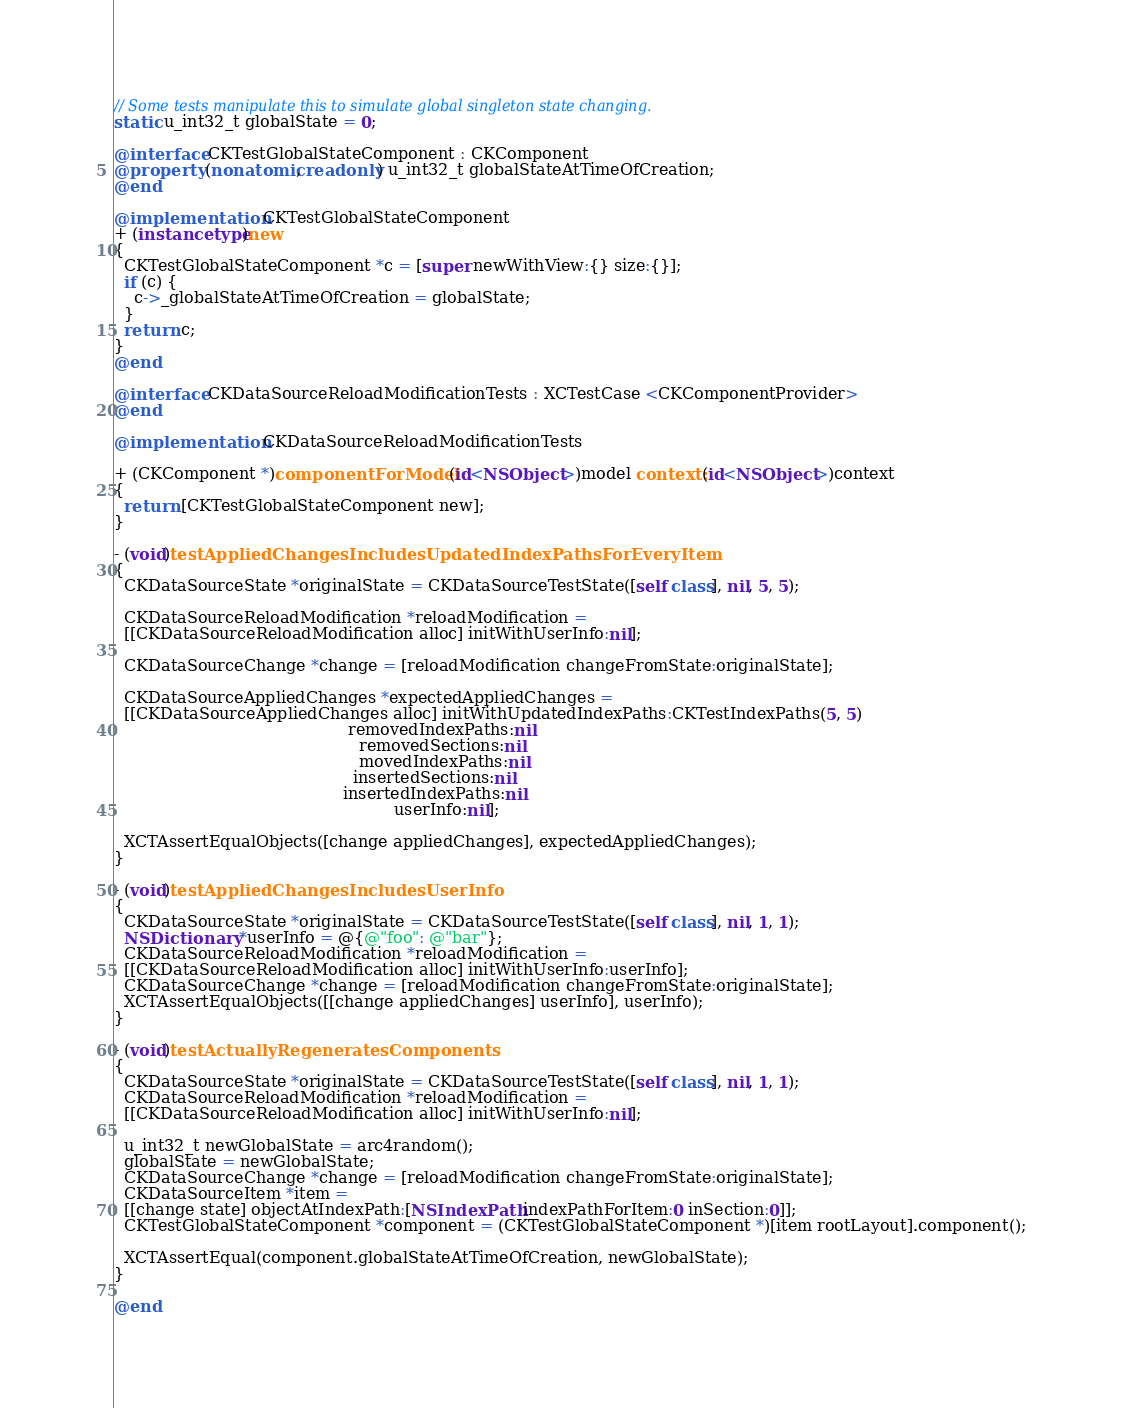<code> <loc_0><loc_0><loc_500><loc_500><_ObjectiveC_>
// Some tests manipulate this to simulate global singleton state changing.
static u_int32_t globalState = 0;

@interface CKTestGlobalStateComponent : CKComponent
@property (nonatomic, readonly) u_int32_t globalStateAtTimeOfCreation;
@end

@implementation CKTestGlobalStateComponent
+ (instancetype)new
{
  CKTestGlobalStateComponent *c = [super newWithView:{} size:{}];
  if (c) {
    c->_globalStateAtTimeOfCreation = globalState;
  }
  return c;
}
@end

@interface CKDataSourceReloadModificationTests : XCTestCase <CKComponentProvider>
@end

@implementation CKDataSourceReloadModificationTests

+ (CKComponent *)componentForModel:(id<NSObject>)model context:(id<NSObject>)context
{
  return [CKTestGlobalStateComponent new];
}

- (void)testAppliedChangesIncludesUpdatedIndexPathsForEveryItem
{
  CKDataSourceState *originalState = CKDataSourceTestState([self class], nil, 5, 5);

  CKDataSourceReloadModification *reloadModification =
  [[CKDataSourceReloadModification alloc] initWithUserInfo:nil];

  CKDataSourceChange *change = [reloadModification changeFromState:originalState];

  CKDataSourceAppliedChanges *expectedAppliedChanges =
  [[CKDataSourceAppliedChanges alloc] initWithUpdatedIndexPaths:CKTestIndexPaths(5, 5)
                                              removedIndexPaths:nil
                                                removedSections:nil
                                                movedIndexPaths:nil
                                               insertedSections:nil
                                             insertedIndexPaths:nil
                                                       userInfo:nil];

  XCTAssertEqualObjects([change appliedChanges], expectedAppliedChanges);
}

- (void)testAppliedChangesIncludesUserInfo
{
  CKDataSourceState *originalState = CKDataSourceTestState([self class], nil, 1, 1);
  NSDictionary *userInfo = @{@"foo": @"bar"};
  CKDataSourceReloadModification *reloadModification =
  [[CKDataSourceReloadModification alloc] initWithUserInfo:userInfo];
  CKDataSourceChange *change = [reloadModification changeFromState:originalState];
  XCTAssertEqualObjects([[change appliedChanges] userInfo], userInfo);
}

- (void)testActuallyRegeneratesComponents
{
  CKDataSourceState *originalState = CKDataSourceTestState([self class], nil, 1, 1);
  CKDataSourceReloadModification *reloadModification =
  [[CKDataSourceReloadModification alloc] initWithUserInfo:nil];

  u_int32_t newGlobalState = arc4random();
  globalState = newGlobalState;
  CKDataSourceChange *change = [reloadModification changeFromState:originalState];
  CKDataSourceItem *item =
  [[change state] objectAtIndexPath:[NSIndexPath indexPathForItem:0 inSection:0]];
  CKTestGlobalStateComponent *component = (CKTestGlobalStateComponent *)[item rootLayout].component();

  XCTAssertEqual(component.globalStateAtTimeOfCreation, newGlobalState);
}

@end
</code> 